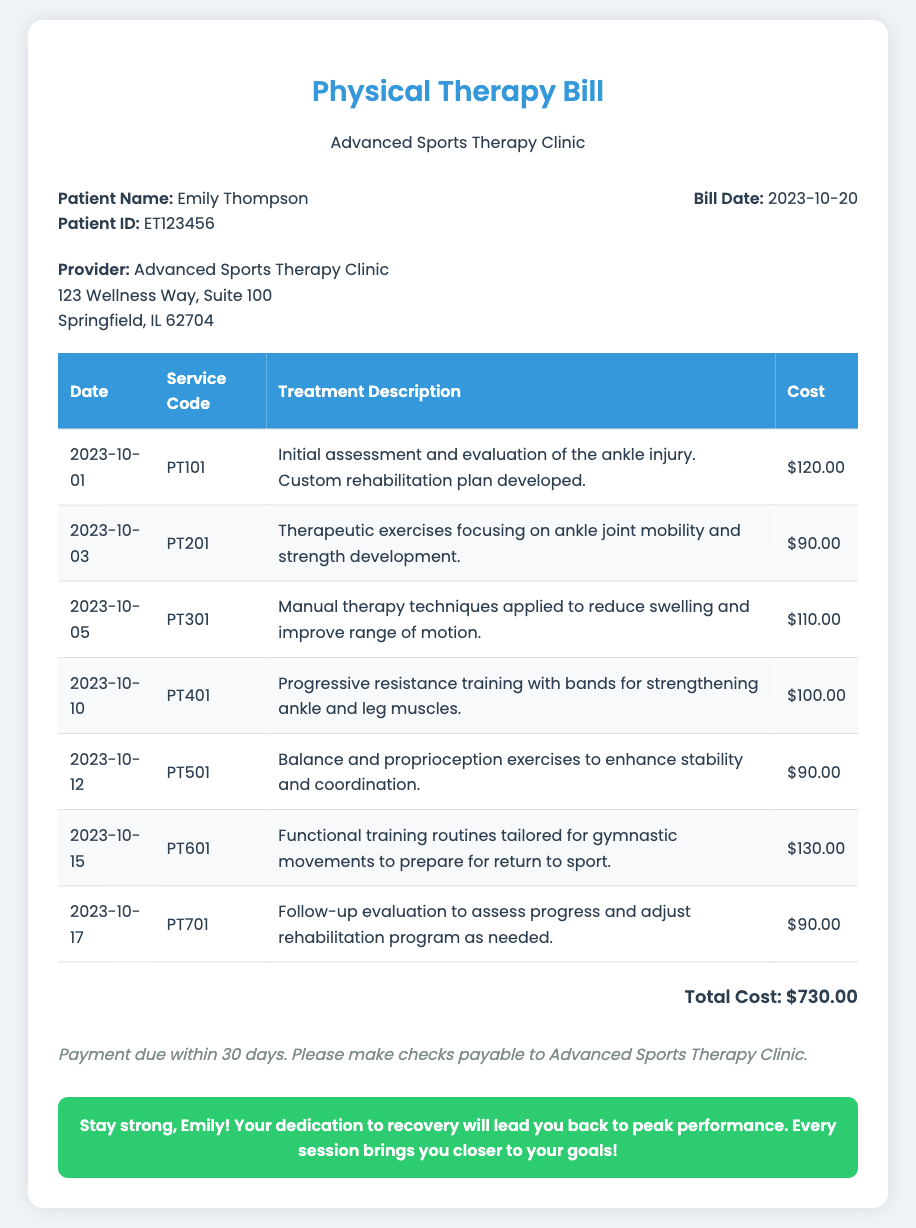what is the patient's name? The patient's name is listed in the document header under 'Patient Name'.
Answer: Emily Thompson what is the total cost of the bill? The total cost is indicated in the section summarizing the costs at the bottom of the bill.
Answer: $730.00 on what date was the initial assessment conducted? The date for the initial assessment is provided in the table under the first treatment entry.
Answer: 2023-10-01 how many rehabilitation sessions were listed in the bill? The number of sessions can be counted from the number of rows in the treatment table.
Answer: 7 which treatment focused on gymnastic movements? The description in the table under treatment indicates the focus of the session.
Answer: Functional training what was the cost of the manual therapy? The cost is shown in the table next to the corresponding treatment session.
Answer: $110.00 when is the payment due? The payment terms section specifies the timeframe in which payment should be made.
Answer: Within 30 days who is the provider of the physical therapy? The provider's name is given in the document header under 'Provider'.
Answer: Advanced Sports Therapy Clinic what type of exercises were included in the rehabilitation sessions? The treatment descriptions indicate various types of exercises aimed at recovery.
Answer: Therapeutic exercises, balance exercises, functional training 